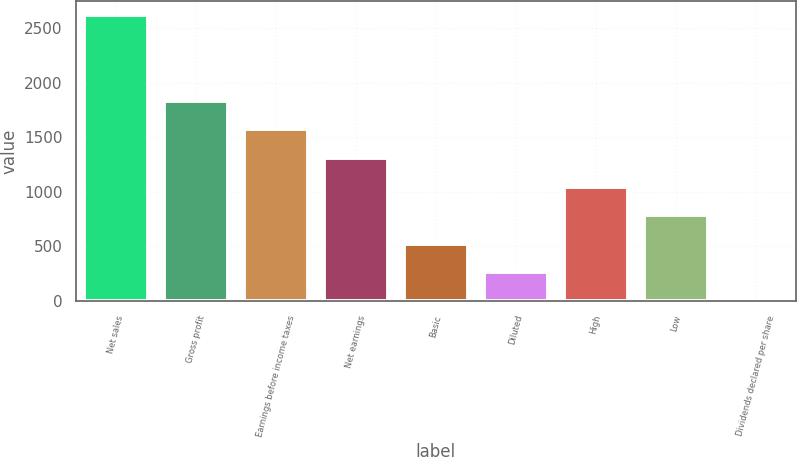Convert chart to OTSL. <chart><loc_0><loc_0><loc_500><loc_500><bar_chart><fcel>Net sales<fcel>Gross profit<fcel>Earnings before income taxes<fcel>Net earnings<fcel>Basic<fcel>Diluted<fcel>High<fcel>Low<fcel>Dividends declared per share<nl><fcel>2618<fcel>1832.73<fcel>1570.96<fcel>1309.19<fcel>523.88<fcel>262.11<fcel>1047.42<fcel>785.65<fcel>0.34<nl></chart> 